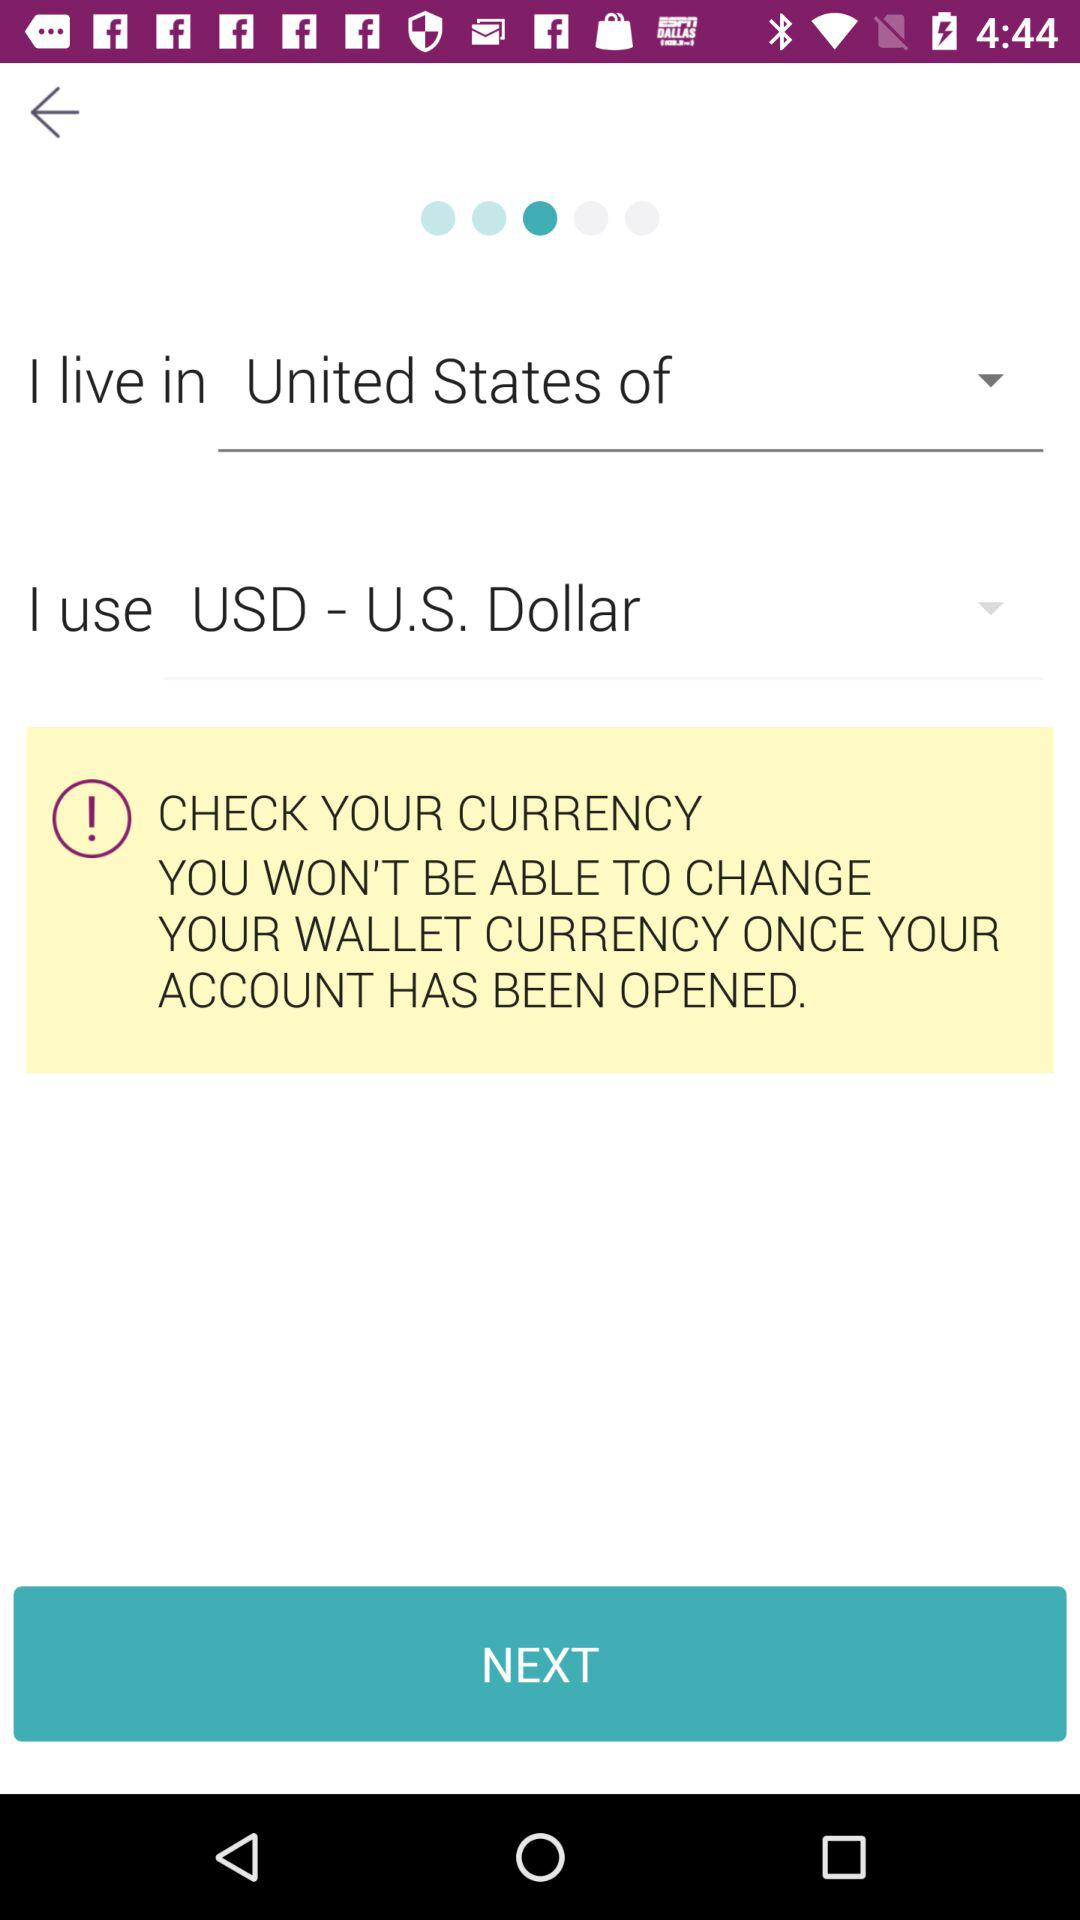What is the selected living country? The selected living country is "United States of". 